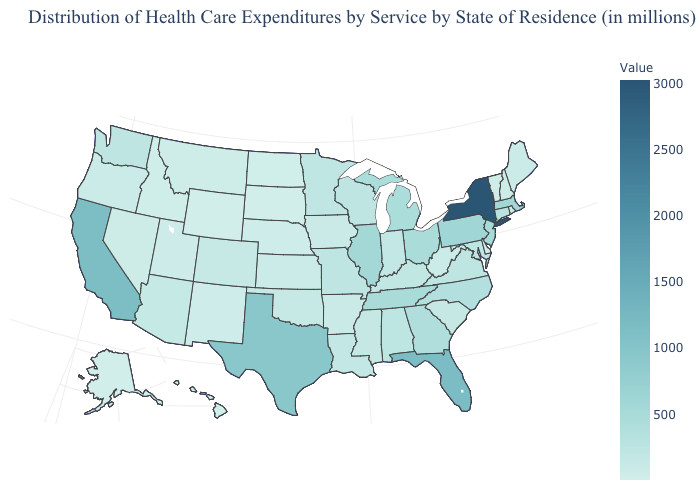Among the states that border Oklahoma , does New Mexico have the lowest value?
Give a very brief answer. Yes. Among the states that border Kentucky , does West Virginia have the lowest value?
Short answer required. Yes. Does Alaska have the lowest value in the USA?
Concise answer only. Yes. Does New York have the highest value in the USA?
Write a very short answer. Yes. Which states hav the highest value in the MidWest?
Answer briefly. Illinois. Does Alaska have the lowest value in the USA?
Keep it brief. Yes. Which states hav the highest value in the Northeast?
Quick response, please. New York. 